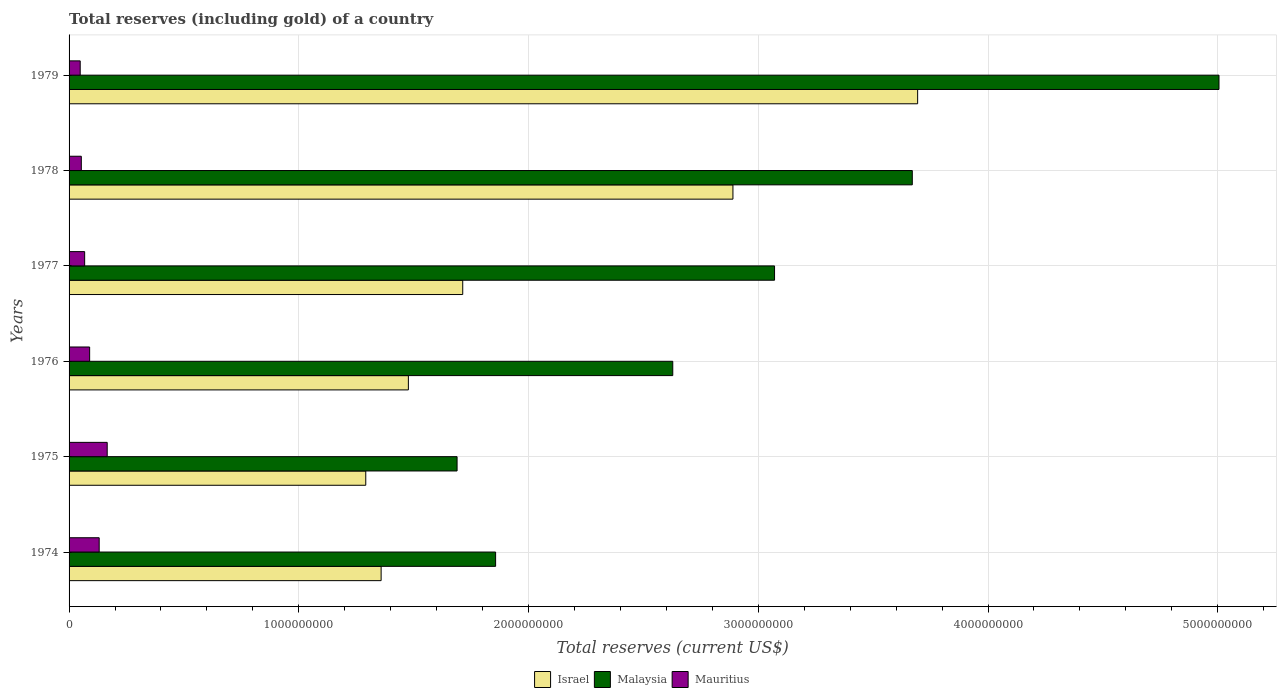How many different coloured bars are there?
Offer a very short reply. 3. How many groups of bars are there?
Make the answer very short. 6. Are the number of bars per tick equal to the number of legend labels?
Provide a short and direct response. Yes. What is the label of the 4th group of bars from the top?
Provide a succinct answer. 1976. In how many cases, is the number of bars for a given year not equal to the number of legend labels?
Ensure brevity in your answer.  0. What is the total reserves (including gold) in Malaysia in 1978?
Provide a succinct answer. 3.67e+09. Across all years, what is the maximum total reserves (including gold) in Mauritius?
Your response must be concise. 1.66e+08. Across all years, what is the minimum total reserves (including gold) in Malaysia?
Give a very brief answer. 1.69e+09. In which year was the total reserves (including gold) in Mauritius maximum?
Offer a very short reply. 1975. In which year was the total reserves (including gold) in Mauritius minimum?
Provide a succinct answer. 1979. What is the total total reserves (including gold) in Mauritius in the graph?
Provide a succinct answer. 5.56e+08. What is the difference between the total reserves (including gold) in Mauritius in 1974 and that in 1979?
Ensure brevity in your answer.  8.26e+07. What is the difference between the total reserves (including gold) in Israel in 1978 and the total reserves (including gold) in Mauritius in 1974?
Provide a succinct answer. 2.76e+09. What is the average total reserves (including gold) in Israel per year?
Your answer should be compact. 2.07e+09. In the year 1978, what is the difference between the total reserves (including gold) in Malaysia and total reserves (including gold) in Mauritius?
Offer a terse response. 3.62e+09. In how many years, is the total reserves (including gold) in Israel greater than 5000000000 US$?
Offer a very short reply. 0. What is the ratio of the total reserves (including gold) in Malaysia in 1977 to that in 1979?
Your answer should be compact. 0.61. What is the difference between the highest and the second highest total reserves (including gold) in Malaysia?
Keep it short and to the point. 1.34e+09. What is the difference between the highest and the lowest total reserves (including gold) in Israel?
Ensure brevity in your answer.  2.40e+09. What does the 2nd bar from the top in 1975 represents?
Offer a very short reply. Malaysia. Is it the case that in every year, the sum of the total reserves (including gold) in Mauritius and total reserves (including gold) in Israel is greater than the total reserves (including gold) in Malaysia?
Offer a very short reply. No. Are all the bars in the graph horizontal?
Ensure brevity in your answer.  Yes. How many years are there in the graph?
Offer a very short reply. 6. What is the difference between two consecutive major ticks on the X-axis?
Your answer should be compact. 1.00e+09. Does the graph contain any zero values?
Your answer should be compact. No. Where does the legend appear in the graph?
Make the answer very short. Bottom center. What is the title of the graph?
Provide a short and direct response. Total reserves (including gold) of a country. What is the label or title of the X-axis?
Provide a succinct answer. Total reserves (current US$). What is the Total reserves (current US$) in Israel in 1974?
Offer a very short reply. 1.36e+09. What is the Total reserves (current US$) in Malaysia in 1974?
Offer a terse response. 1.86e+09. What is the Total reserves (current US$) in Mauritius in 1974?
Offer a terse response. 1.31e+08. What is the Total reserves (current US$) of Israel in 1975?
Offer a very short reply. 1.29e+09. What is the Total reserves (current US$) in Malaysia in 1975?
Offer a terse response. 1.69e+09. What is the Total reserves (current US$) in Mauritius in 1975?
Your answer should be compact. 1.66e+08. What is the Total reserves (current US$) of Israel in 1976?
Your answer should be compact. 1.48e+09. What is the Total reserves (current US$) of Malaysia in 1976?
Your response must be concise. 2.63e+09. What is the Total reserves (current US$) in Mauritius in 1976?
Your answer should be compact. 8.95e+07. What is the Total reserves (current US$) in Israel in 1977?
Your response must be concise. 1.71e+09. What is the Total reserves (current US$) of Malaysia in 1977?
Your answer should be very brief. 3.07e+09. What is the Total reserves (current US$) in Mauritius in 1977?
Offer a terse response. 6.79e+07. What is the Total reserves (current US$) in Israel in 1978?
Make the answer very short. 2.89e+09. What is the Total reserves (current US$) in Malaysia in 1978?
Your answer should be very brief. 3.67e+09. What is the Total reserves (current US$) of Mauritius in 1978?
Your answer should be very brief. 5.33e+07. What is the Total reserves (current US$) of Israel in 1979?
Provide a succinct answer. 3.69e+09. What is the Total reserves (current US$) in Malaysia in 1979?
Offer a very short reply. 5.01e+09. What is the Total reserves (current US$) in Mauritius in 1979?
Your answer should be compact. 4.84e+07. Across all years, what is the maximum Total reserves (current US$) in Israel?
Give a very brief answer. 3.69e+09. Across all years, what is the maximum Total reserves (current US$) of Malaysia?
Your answer should be compact. 5.01e+09. Across all years, what is the maximum Total reserves (current US$) in Mauritius?
Give a very brief answer. 1.66e+08. Across all years, what is the minimum Total reserves (current US$) in Israel?
Offer a terse response. 1.29e+09. Across all years, what is the minimum Total reserves (current US$) in Malaysia?
Give a very brief answer. 1.69e+09. Across all years, what is the minimum Total reserves (current US$) of Mauritius?
Give a very brief answer. 4.84e+07. What is the total Total reserves (current US$) of Israel in the graph?
Offer a terse response. 1.24e+1. What is the total Total reserves (current US$) in Malaysia in the graph?
Your response must be concise. 1.79e+1. What is the total Total reserves (current US$) of Mauritius in the graph?
Provide a succinct answer. 5.56e+08. What is the difference between the Total reserves (current US$) in Israel in 1974 and that in 1975?
Your answer should be very brief. 6.68e+07. What is the difference between the Total reserves (current US$) of Malaysia in 1974 and that in 1975?
Offer a very short reply. 1.68e+08. What is the difference between the Total reserves (current US$) in Mauritius in 1974 and that in 1975?
Offer a terse response. -3.49e+07. What is the difference between the Total reserves (current US$) of Israel in 1974 and that in 1976?
Your answer should be compact. -1.19e+08. What is the difference between the Total reserves (current US$) of Malaysia in 1974 and that in 1976?
Offer a very short reply. -7.71e+08. What is the difference between the Total reserves (current US$) in Mauritius in 1974 and that in 1976?
Offer a very short reply. 4.16e+07. What is the difference between the Total reserves (current US$) in Israel in 1974 and that in 1977?
Keep it short and to the point. -3.55e+08. What is the difference between the Total reserves (current US$) in Malaysia in 1974 and that in 1977?
Make the answer very short. -1.21e+09. What is the difference between the Total reserves (current US$) of Mauritius in 1974 and that in 1977?
Ensure brevity in your answer.  6.32e+07. What is the difference between the Total reserves (current US$) of Israel in 1974 and that in 1978?
Keep it short and to the point. -1.53e+09. What is the difference between the Total reserves (current US$) of Malaysia in 1974 and that in 1978?
Provide a short and direct response. -1.81e+09. What is the difference between the Total reserves (current US$) in Mauritius in 1974 and that in 1978?
Offer a terse response. 7.78e+07. What is the difference between the Total reserves (current US$) of Israel in 1974 and that in 1979?
Keep it short and to the point. -2.34e+09. What is the difference between the Total reserves (current US$) of Malaysia in 1974 and that in 1979?
Give a very brief answer. -3.15e+09. What is the difference between the Total reserves (current US$) of Mauritius in 1974 and that in 1979?
Ensure brevity in your answer.  8.26e+07. What is the difference between the Total reserves (current US$) of Israel in 1975 and that in 1976?
Your answer should be compact. -1.85e+08. What is the difference between the Total reserves (current US$) of Malaysia in 1975 and that in 1976?
Provide a short and direct response. -9.39e+08. What is the difference between the Total reserves (current US$) in Mauritius in 1975 and that in 1976?
Ensure brevity in your answer.  7.65e+07. What is the difference between the Total reserves (current US$) in Israel in 1975 and that in 1977?
Your answer should be very brief. -4.22e+08. What is the difference between the Total reserves (current US$) of Malaysia in 1975 and that in 1977?
Give a very brief answer. -1.38e+09. What is the difference between the Total reserves (current US$) of Mauritius in 1975 and that in 1977?
Give a very brief answer. 9.81e+07. What is the difference between the Total reserves (current US$) in Israel in 1975 and that in 1978?
Your answer should be very brief. -1.60e+09. What is the difference between the Total reserves (current US$) in Malaysia in 1975 and that in 1978?
Your answer should be compact. -1.98e+09. What is the difference between the Total reserves (current US$) of Mauritius in 1975 and that in 1978?
Your answer should be compact. 1.13e+08. What is the difference between the Total reserves (current US$) in Israel in 1975 and that in 1979?
Offer a terse response. -2.40e+09. What is the difference between the Total reserves (current US$) in Malaysia in 1975 and that in 1979?
Your answer should be very brief. -3.32e+09. What is the difference between the Total reserves (current US$) in Mauritius in 1975 and that in 1979?
Your answer should be compact. 1.18e+08. What is the difference between the Total reserves (current US$) of Israel in 1976 and that in 1977?
Ensure brevity in your answer.  -2.37e+08. What is the difference between the Total reserves (current US$) in Malaysia in 1976 and that in 1977?
Ensure brevity in your answer.  -4.43e+08. What is the difference between the Total reserves (current US$) in Mauritius in 1976 and that in 1977?
Keep it short and to the point. 2.16e+07. What is the difference between the Total reserves (current US$) of Israel in 1976 and that in 1978?
Give a very brief answer. -1.41e+09. What is the difference between the Total reserves (current US$) of Malaysia in 1976 and that in 1978?
Your answer should be compact. -1.04e+09. What is the difference between the Total reserves (current US$) of Mauritius in 1976 and that in 1978?
Offer a very short reply. 3.63e+07. What is the difference between the Total reserves (current US$) in Israel in 1976 and that in 1979?
Keep it short and to the point. -2.22e+09. What is the difference between the Total reserves (current US$) of Malaysia in 1976 and that in 1979?
Make the answer very short. -2.38e+09. What is the difference between the Total reserves (current US$) in Mauritius in 1976 and that in 1979?
Give a very brief answer. 4.11e+07. What is the difference between the Total reserves (current US$) in Israel in 1977 and that in 1978?
Your answer should be very brief. -1.18e+09. What is the difference between the Total reserves (current US$) of Malaysia in 1977 and that in 1978?
Keep it short and to the point. -6.00e+08. What is the difference between the Total reserves (current US$) in Mauritius in 1977 and that in 1978?
Provide a short and direct response. 1.46e+07. What is the difference between the Total reserves (current US$) of Israel in 1977 and that in 1979?
Your answer should be compact. -1.98e+09. What is the difference between the Total reserves (current US$) of Malaysia in 1977 and that in 1979?
Offer a very short reply. -1.93e+09. What is the difference between the Total reserves (current US$) in Mauritius in 1977 and that in 1979?
Offer a terse response. 1.94e+07. What is the difference between the Total reserves (current US$) of Israel in 1978 and that in 1979?
Keep it short and to the point. -8.04e+08. What is the difference between the Total reserves (current US$) in Malaysia in 1978 and that in 1979?
Your answer should be compact. -1.34e+09. What is the difference between the Total reserves (current US$) of Mauritius in 1978 and that in 1979?
Give a very brief answer. 4.83e+06. What is the difference between the Total reserves (current US$) of Israel in 1974 and the Total reserves (current US$) of Malaysia in 1975?
Provide a succinct answer. -3.31e+08. What is the difference between the Total reserves (current US$) in Israel in 1974 and the Total reserves (current US$) in Mauritius in 1975?
Keep it short and to the point. 1.19e+09. What is the difference between the Total reserves (current US$) of Malaysia in 1974 and the Total reserves (current US$) of Mauritius in 1975?
Offer a very short reply. 1.69e+09. What is the difference between the Total reserves (current US$) in Israel in 1974 and the Total reserves (current US$) in Malaysia in 1976?
Your answer should be very brief. -1.27e+09. What is the difference between the Total reserves (current US$) of Israel in 1974 and the Total reserves (current US$) of Mauritius in 1976?
Your response must be concise. 1.27e+09. What is the difference between the Total reserves (current US$) of Malaysia in 1974 and the Total reserves (current US$) of Mauritius in 1976?
Provide a short and direct response. 1.77e+09. What is the difference between the Total reserves (current US$) of Israel in 1974 and the Total reserves (current US$) of Malaysia in 1977?
Your answer should be compact. -1.71e+09. What is the difference between the Total reserves (current US$) in Israel in 1974 and the Total reserves (current US$) in Mauritius in 1977?
Keep it short and to the point. 1.29e+09. What is the difference between the Total reserves (current US$) in Malaysia in 1974 and the Total reserves (current US$) in Mauritius in 1977?
Your answer should be compact. 1.79e+09. What is the difference between the Total reserves (current US$) in Israel in 1974 and the Total reserves (current US$) in Malaysia in 1978?
Give a very brief answer. -2.31e+09. What is the difference between the Total reserves (current US$) of Israel in 1974 and the Total reserves (current US$) of Mauritius in 1978?
Provide a short and direct response. 1.31e+09. What is the difference between the Total reserves (current US$) of Malaysia in 1974 and the Total reserves (current US$) of Mauritius in 1978?
Your response must be concise. 1.80e+09. What is the difference between the Total reserves (current US$) of Israel in 1974 and the Total reserves (current US$) of Malaysia in 1979?
Your answer should be compact. -3.65e+09. What is the difference between the Total reserves (current US$) of Israel in 1974 and the Total reserves (current US$) of Mauritius in 1979?
Ensure brevity in your answer.  1.31e+09. What is the difference between the Total reserves (current US$) of Malaysia in 1974 and the Total reserves (current US$) of Mauritius in 1979?
Your answer should be compact. 1.81e+09. What is the difference between the Total reserves (current US$) in Israel in 1975 and the Total reserves (current US$) in Malaysia in 1976?
Keep it short and to the point. -1.34e+09. What is the difference between the Total reserves (current US$) in Israel in 1975 and the Total reserves (current US$) in Mauritius in 1976?
Your answer should be very brief. 1.20e+09. What is the difference between the Total reserves (current US$) of Malaysia in 1975 and the Total reserves (current US$) of Mauritius in 1976?
Give a very brief answer. 1.60e+09. What is the difference between the Total reserves (current US$) in Israel in 1975 and the Total reserves (current US$) in Malaysia in 1977?
Your response must be concise. -1.78e+09. What is the difference between the Total reserves (current US$) of Israel in 1975 and the Total reserves (current US$) of Mauritius in 1977?
Keep it short and to the point. 1.22e+09. What is the difference between the Total reserves (current US$) in Malaysia in 1975 and the Total reserves (current US$) in Mauritius in 1977?
Provide a succinct answer. 1.62e+09. What is the difference between the Total reserves (current US$) in Israel in 1975 and the Total reserves (current US$) in Malaysia in 1978?
Offer a terse response. -2.38e+09. What is the difference between the Total reserves (current US$) in Israel in 1975 and the Total reserves (current US$) in Mauritius in 1978?
Your answer should be very brief. 1.24e+09. What is the difference between the Total reserves (current US$) in Malaysia in 1975 and the Total reserves (current US$) in Mauritius in 1978?
Your answer should be very brief. 1.64e+09. What is the difference between the Total reserves (current US$) in Israel in 1975 and the Total reserves (current US$) in Malaysia in 1979?
Keep it short and to the point. -3.71e+09. What is the difference between the Total reserves (current US$) of Israel in 1975 and the Total reserves (current US$) of Mauritius in 1979?
Offer a terse response. 1.24e+09. What is the difference between the Total reserves (current US$) of Malaysia in 1975 and the Total reserves (current US$) of Mauritius in 1979?
Your answer should be compact. 1.64e+09. What is the difference between the Total reserves (current US$) in Israel in 1976 and the Total reserves (current US$) in Malaysia in 1977?
Provide a succinct answer. -1.59e+09. What is the difference between the Total reserves (current US$) of Israel in 1976 and the Total reserves (current US$) of Mauritius in 1977?
Provide a succinct answer. 1.41e+09. What is the difference between the Total reserves (current US$) of Malaysia in 1976 and the Total reserves (current US$) of Mauritius in 1977?
Ensure brevity in your answer.  2.56e+09. What is the difference between the Total reserves (current US$) of Israel in 1976 and the Total reserves (current US$) of Malaysia in 1978?
Make the answer very short. -2.19e+09. What is the difference between the Total reserves (current US$) in Israel in 1976 and the Total reserves (current US$) in Mauritius in 1978?
Ensure brevity in your answer.  1.42e+09. What is the difference between the Total reserves (current US$) in Malaysia in 1976 and the Total reserves (current US$) in Mauritius in 1978?
Provide a short and direct response. 2.57e+09. What is the difference between the Total reserves (current US$) of Israel in 1976 and the Total reserves (current US$) of Malaysia in 1979?
Your answer should be compact. -3.53e+09. What is the difference between the Total reserves (current US$) of Israel in 1976 and the Total reserves (current US$) of Mauritius in 1979?
Your response must be concise. 1.43e+09. What is the difference between the Total reserves (current US$) in Malaysia in 1976 and the Total reserves (current US$) in Mauritius in 1979?
Offer a very short reply. 2.58e+09. What is the difference between the Total reserves (current US$) in Israel in 1977 and the Total reserves (current US$) in Malaysia in 1978?
Make the answer very short. -1.96e+09. What is the difference between the Total reserves (current US$) in Israel in 1977 and the Total reserves (current US$) in Mauritius in 1978?
Ensure brevity in your answer.  1.66e+09. What is the difference between the Total reserves (current US$) of Malaysia in 1977 and the Total reserves (current US$) of Mauritius in 1978?
Keep it short and to the point. 3.02e+09. What is the difference between the Total reserves (current US$) in Israel in 1977 and the Total reserves (current US$) in Malaysia in 1979?
Your answer should be compact. -3.29e+09. What is the difference between the Total reserves (current US$) in Israel in 1977 and the Total reserves (current US$) in Mauritius in 1979?
Provide a succinct answer. 1.67e+09. What is the difference between the Total reserves (current US$) in Malaysia in 1977 and the Total reserves (current US$) in Mauritius in 1979?
Your answer should be very brief. 3.02e+09. What is the difference between the Total reserves (current US$) of Israel in 1978 and the Total reserves (current US$) of Malaysia in 1979?
Offer a very short reply. -2.12e+09. What is the difference between the Total reserves (current US$) of Israel in 1978 and the Total reserves (current US$) of Mauritius in 1979?
Keep it short and to the point. 2.84e+09. What is the difference between the Total reserves (current US$) of Malaysia in 1978 and the Total reserves (current US$) of Mauritius in 1979?
Provide a succinct answer. 3.62e+09. What is the average Total reserves (current US$) in Israel per year?
Your answer should be compact. 2.07e+09. What is the average Total reserves (current US$) in Malaysia per year?
Offer a terse response. 2.99e+09. What is the average Total reserves (current US$) in Mauritius per year?
Give a very brief answer. 9.27e+07. In the year 1974, what is the difference between the Total reserves (current US$) of Israel and Total reserves (current US$) of Malaysia?
Your answer should be compact. -4.98e+08. In the year 1974, what is the difference between the Total reserves (current US$) of Israel and Total reserves (current US$) of Mauritius?
Your response must be concise. 1.23e+09. In the year 1974, what is the difference between the Total reserves (current US$) of Malaysia and Total reserves (current US$) of Mauritius?
Your answer should be compact. 1.73e+09. In the year 1975, what is the difference between the Total reserves (current US$) in Israel and Total reserves (current US$) in Malaysia?
Provide a short and direct response. -3.97e+08. In the year 1975, what is the difference between the Total reserves (current US$) of Israel and Total reserves (current US$) of Mauritius?
Provide a short and direct response. 1.13e+09. In the year 1975, what is the difference between the Total reserves (current US$) in Malaysia and Total reserves (current US$) in Mauritius?
Make the answer very short. 1.52e+09. In the year 1976, what is the difference between the Total reserves (current US$) of Israel and Total reserves (current US$) of Malaysia?
Provide a short and direct response. -1.15e+09. In the year 1976, what is the difference between the Total reserves (current US$) in Israel and Total reserves (current US$) in Mauritius?
Make the answer very short. 1.39e+09. In the year 1976, what is the difference between the Total reserves (current US$) in Malaysia and Total reserves (current US$) in Mauritius?
Your answer should be compact. 2.54e+09. In the year 1977, what is the difference between the Total reserves (current US$) in Israel and Total reserves (current US$) in Malaysia?
Provide a succinct answer. -1.36e+09. In the year 1977, what is the difference between the Total reserves (current US$) of Israel and Total reserves (current US$) of Mauritius?
Make the answer very short. 1.65e+09. In the year 1977, what is the difference between the Total reserves (current US$) of Malaysia and Total reserves (current US$) of Mauritius?
Offer a very short reply. 3.00e+09. In the year 1978, what is the difference between the Total reserves (current US$) in Israel and Total reserves (current US$) in Malaysia?
Your answer should be very brief. -7.81e+08. In the year 1978, what is the difference between the Total reserves (current US$) of Israel and Total reserves (current US$) of Mauritius?
Make the answer very short. 2.84e+09. In the year 1978, what is the difference between the Total reserves (current US$) of Malaysia and Total reserves (current US$) of Mauritius?
Give a very brief answer. 3.62e+09. In the year 1979, what is the difference between the Total reserves (current US$) of Israel and Total reserves (current US$) of Malaysia?
Your answer should be very brief. -1.31e+09. In the year 1979, what is the difference between the Total reserves (current US$) of Israel and Total reserves (current US$) of Mauritius?
Your answer should be very brief. 3.65e+09. In the year 1979, what is the difference between the Total reserves (current US$) of Malaysia and Total reserves (current US$) of Mauritius?
Offer a terse response. 4.96e+09. What is the ratio of the Total reserves (current US$) of Israel in 1974 to that in 1975?
Give a very brief answer. 1.05. What is the ratio of the Total reserves (current US$) of Malaysia in 1974 to that in 1975?
Your answer should be compact. 1.1. What is the ratio of the Total reserves (current US$) in Mauritius in 1974 to that in 1975?
Your answer should be compact. 0.79. What is the ratio of the Total reserves (current US$) in Israel in 1974 to that in 1976?
Your response must be concise. 0.92. What is the ratio of the Total reserves (current US$) in Malaysia in 1974 to that in 1976?
Offer a terse response. 0.71. What is the ratio of the Total reserves (current US$) of Mauritius in 1974 to that in 1976?
Ensure brevity in your answer.  1.46. What is the ratio of the Total reserves (current US$) of Israel in 1974 to that in 1977?
Keep it short and to the point. 0.79. What is the ratio of the Total reserves (current US$) of Malaysia in 1974 to that in 1977?
Keep it short and to the point. 0.6. What is the ratio of the Total reserves (current US$) of Mauritius in 1974 to that in 1977?
Keep it short and to the point. 1.93. What is the ratio of the Total reserves (current US$) of Israel in 1974 to that in 1978?
Your response must be concise. 0.47. What is the ratio of the Total reserves (current US$) in Malaysia in 1974 to that in 1978?
Offer a very short reply. 0.51. What is the ratio of the Total reserves (current US$) in Mauritius in 1974 to that in 1978?
Keep it short and to the point. 2.46. What is the ratio of the Total reserves (current US$) in Israel in 1974 to that in 1979?
Make the answer very short. 0.37. What is the ratio of the Total reserves (current US$) of Malaysia in 1974 to that in 1979?
Provide a succinct answer. 0.37. What is the ratio of the Total reserves (current US$) of Mauritius in 1974 to that in 1979?
Your response must be concise. 2.71. What is the ratio of the Total reserves (current US$) of Israel in 1975 to that in 1976?
Ensure brevity in your answer.  0.87. What is the ratio of the Total reserves (current US$) of Malaysia in 1975 to that in 1976?
Your answer should be very brief. 0.64. What is the ratio of the Total reserves (current US$) of Mauritius in 1975 to that in 1976?
Provide a short and direct response. 1.85. What is the ratio of the Total reserves (current US$) of Israel in 1975 to that in 1977?
Offer a terse response. 0.75. What is the ratio of the Total reserves (current US$) of Malaysia in 1975 to that in 1977?
Offer a terse response. 0.55. What is the ratio of the Total reserves (current US$) of Mauritius in 1975 to that in 1977?
Offer a terse response. 2.45. What is the ratio of the Total reserves (current US$) of Israel in 1975 to that in 1978?
Your answer should be compact. 0.45. What is the ratio of the Total reserves (current US$) in Malaysia in 1975 to that in 1978?
Your answer should be compact. 0.46. What is the ratio of the Total reserves (current US$) of Mauritius in 1975 to that in 1978?
Your answer should be very brief. 3.12. What is the ratio of the Total reserves (current US$) in Israel in 1975 to that in 1979?
Ensure brevity in your answer.  0.35. What is the ratio of the Total reserves (current US$) of Malaysia in 1975 to that in 1979?
Offer a terse response. 0.34. What is the ratio of the Total reserves (current US$) in Mauritius in 1975 to that in 1979?
Provide a short and direct response. 3.43. What is the ratio of the Total reserves (current US$) in Israel in 1976 to that in 1977?
Provide a succinct answer. 0.86. What is the ratio of the Total reserves (current US$) of Malaysia in 1976 to that in 1977?
Make the answer very short. 0.86. What is the ratio of the Total reserves (current US$) in Mauritius in 1976 to that in 1977?
Provide a succinct answer. 1.32. What is the ratio of the Total reserves (current US$) in Israel in 1976 to that in 1978?
Ensure brevity in your answer.  0.51. What is the ratio of the Total reserves (current US$) of Malaysia in 1976 to that in 1978?
Your answer should be very brief. 0.72. What is the ratio of the Total reserves (current US$) of Mauritius in 1976 to that in 1978?
Provide a short and direct response. 1.68. What is the ratio of the Total reserves (current US$) in Israel in 1976 to that in 1979?
Your answer should be very brief. 0.4. What is the ratio of the Total reserves (current US$) in Malaysia in 1976 to that in 1979?
Make the answer very short. 0.53. What is the ratio of the Total reserves (current US$) in Mauritius in 1976 to that in 1979?
Your answer should be compact. 1.85. What is the ratio of the Total reserves (current US$) of Israel in 1977 to that in 1978?
Your answer should be compact. 0.59. What is the ratio of the Total reserves (current US$) of Malaysia in 1977 to that in 1978?
Ensure brevity in your answer.  0.84. What is the ratio of the Total reserves (current US$) in Mauritius in 1977 to that in 1978?
Keep it short and to the point. 1.27. What is the ratio of the Total reserves (current US$) in Israel in 1977 to that in 1979?
Offer a terse response. 0.46. What is the ratio of the Total reserves (current US$) in Malaysia in 1977 to that in 1979?
Provide a short and direct response. 0.61. What is the ratio of the Total reserves (current US$) of Mauritius in 1977 to that in 1979?
Make the answer very short. 1.4. What is the ratio of the Total reserves (current US$) in Israel in 1978 to that in 1979?
Your response must be concise. 0.78. What is the ratio of the Total reserves (current US$) of Malaysia in 1978 to that in 1979?
Make the answer very short. 0.73. What is the ratio of the Total reserves (current US$) of Mauritius in 1978 to that in 1979?
Your response must be concise. 1.1. What is the difference between the highest and the second highest Total reserves (current US$) of Israel?
Offer a very short reply. 8.04e+08. What is the difference between the highest and the second highest Total reserves (current US$) in Malaysia?
Your answer should be very brief. 1.34e+09. What is the difference between the highest and the second highest Total reserves (current US$) in Mauritius?
Keep it short and to the point. 3.49e+07. What is the difference between the highest and the lowest Total reserves (current US$) in Israel?
Offer a terse response. 2.40e+09. What is the difference between the highest and the lowest Total reserves (current US$) of Malaysia?
Give a very brief answer. 3.32e+09. What is the difference between the highest and the lowest Total reserves (current US$) in Mauritius?
Your response must be concise. 1.18e+08. 